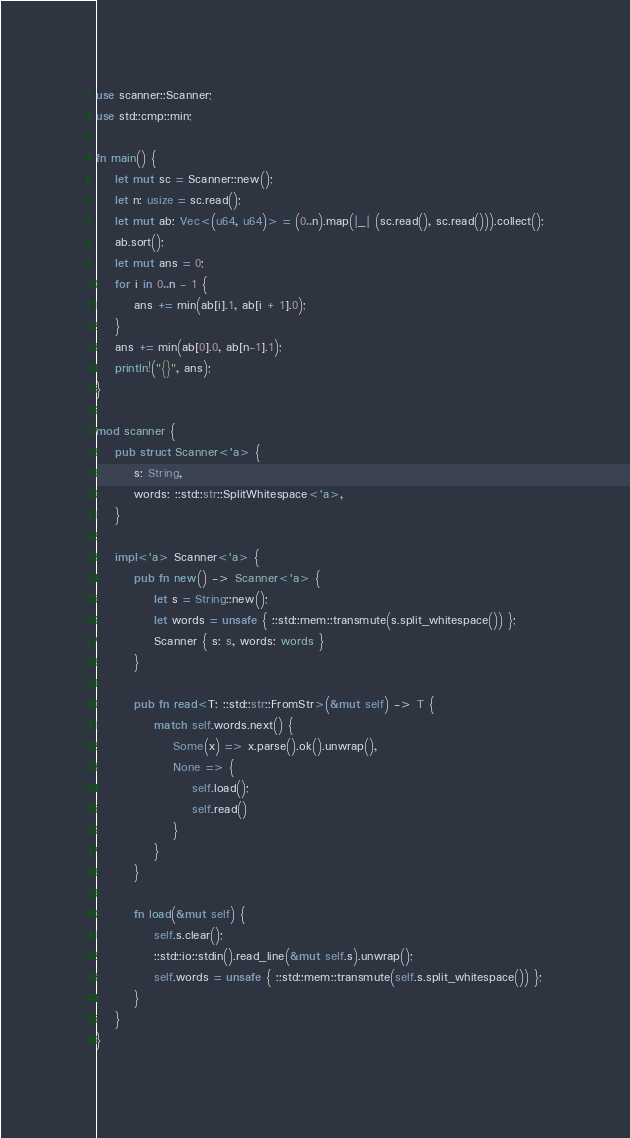Convert code to text. <code><loc_0><loc_0><loc_500><loc_500><_Rust_>use scanner::Scanner;
use std::cmp::min;

fn main() {
    let mut sc = Scanner::new();
    let n: usize = sc.read();
    let mut ab: Vec<(u64, u64)> = (0..n).map(|_| (sc.read(), sc.read())).collect();
    ab.sort();
    let mut ans = 0;
    for i in 0..n - 1 {
        ans += min(ab[i].1, ab[i + 1].0);
    }
    ans += min(ab[0].0, ab[n-1].1);
    println!("{}", ans);
}

mod scanner {
    pub struct Scanner<'a> {
        s: String,
        words: ::std::str::SplitWhitespace<'a>,
    }

    impl<'a> Scanner<'a> {
        pub fn new() -> Scanner<'a> {
            let s = String::new();
            let words = unsafe { ::std::mem::transmute(s.split_whitespace()) };
            Scanner { s: s, words: words }
        }

        pub fn read<T: ::std::str::FromStr>(&mut self) -> T {
            match self.words.next() {
                Some(x) => x.parse().ok().unwrap(),
                None => {
                    self.load();
                    self.read()
                }
            }
        }

        fn load(&mut self) {
            self.s.clear();
            ::std::io::stdin().read_line(&mut self.s).unwrap();
            self.words = unsafe { ::std::mem::transmute(self.s.split_whitespace()) };
        }
    }
}
</code> 